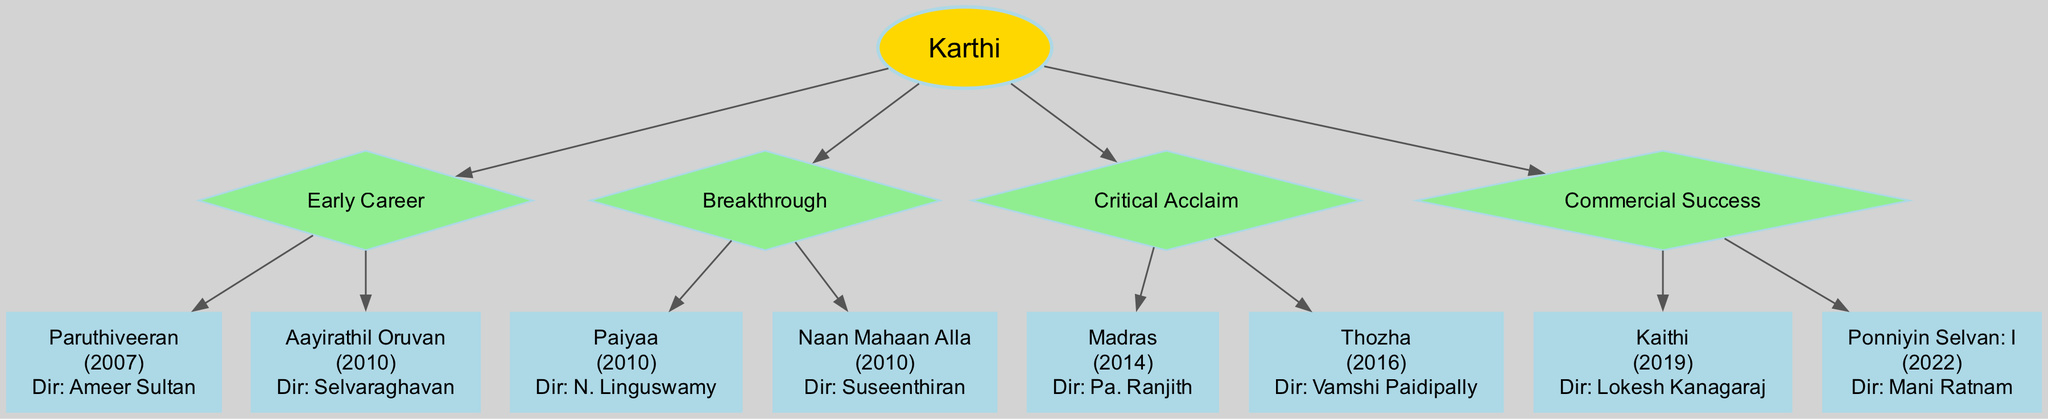What is the name of Karthi's first film in his filmography? The diagram indicates that Karthi's first film is "Paruthiveeran," which is listed under the "Early Career" branch.
Answer: Paruthiveeran How many films are listed under the 'Breakthrough' category? The 'Breakthrough' branch shows two films: "Paiyaa" and "Naan Mahaan Alla." Therefore, there are two films in this category.
Answer: 2 Which film directed by Mani Ratnam is included in Karthi's filmography? The diagram points out that "Ponniyin Selvan: I," directed by Mani Ratnam, is categorized under the "Commercial Success" branch.
Answer: Ponniyin Selvan: I What year was "Aayirathil Oruvan" released? Referring to the "Early Career" branch, "Aayirathil Oruvan" appears with the release year of 2010.
Answer: 2010 Which category includes films released in 2016? The "Critical Acclaim" branch includes "Thozha," which was released in 2016. Thus, the answer connects the film to its specific category.
Answer: Critical Acclaim What is the total number of branches in Karthi's Notable Filmography? The diagram shows four distinct branches: "Early Career," "Breakthrough," "Critical Acclaim," and "Commercial Success." Therefore, the total count is four branches.
Answer: 4 Which director worked on Karthi's film "Madras"? The film "Madras," found in the "Critical Acclaim" branch, is directed by Pa. Ranjith, as indicated in the diagram.
Answer: Pa. Ranjith Which film signifies Karthi's return to commercial success in 2022? The diagram specifies that "Ponniyin Selvan: I" is the film released in 2022 under the "Commercial Success" branch.
Answer: Ponniyin Selvan: I What is the last film listed in the "Early Career" section? The diagram lists "Aayirathil Oruvan" as the second and last film under the "Early Career" branch.
Answer: Aayirathil Oruvan 